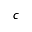<formula> <loc_0><loc_0><loc_500><loc_500>c</formula> 